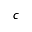<formula> <loc_0><loc_0><loc_500><loc_500>c</formula> 